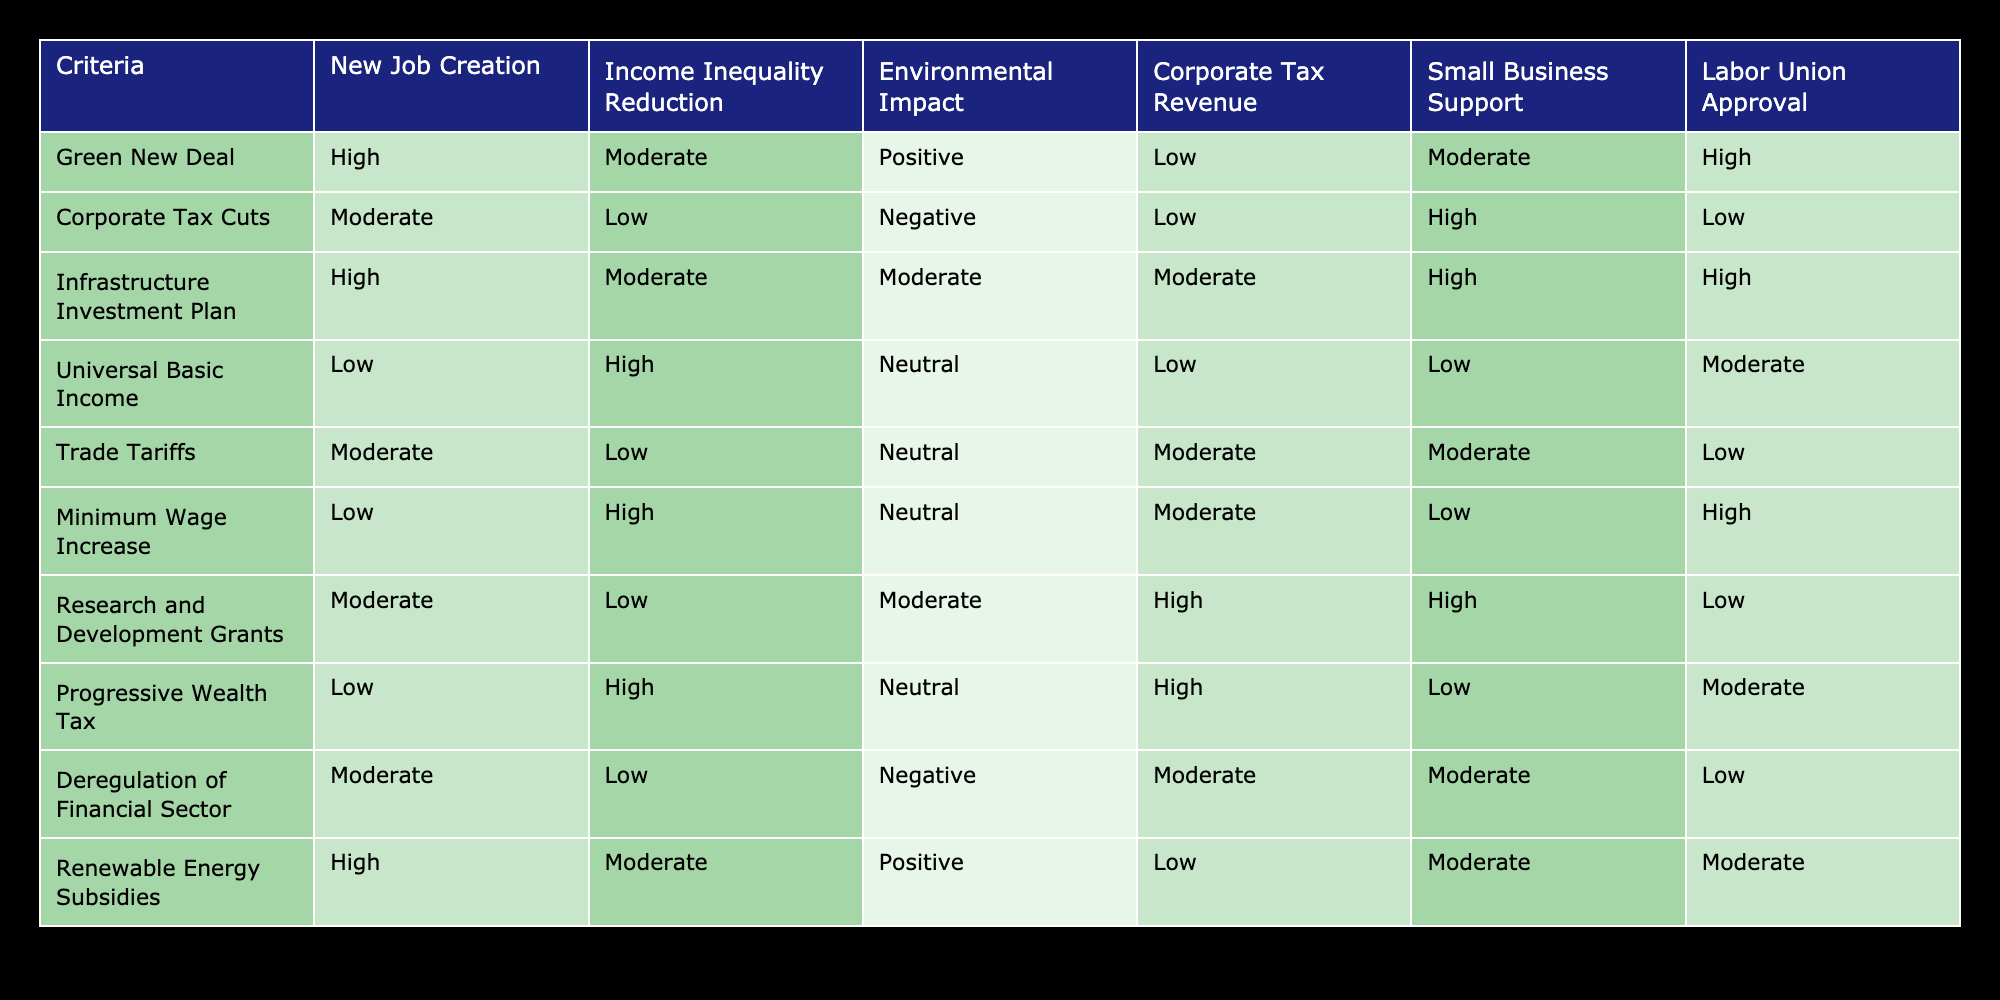What policy has the highest corporate tax revenue? From the table, the "Research and Development Grants" has a "High" rating for Corporate Tax Revenue.
Answer: Research and Development Grants Which policies support small businesses? The "Corporate Tax Cuts," "Infrastructure Investment Plan," and "Renewable Energy Subsidies" all have a "High" rating for Small Business Support.
Answer: Corporate Tax Cuts, Infrastructure Investment Plan, Renewable Energy Subsidies Is there any policy with both high job creation and high corporate tax revenue? By checking the table, no policies have both a "High" rating for New Job Creation and Corporate Tax Revenue simultaneously.
Answer: No Which policy has the lowest rating for income inequality reduction? The "Corporate Tax Cuts" have a "Low" rating for Income Inequality Reduction.
Answer: Corporate Tax Cuts What is the average rating for environmental impact across the policies? The environmental impact ratings from the table: Positive (3), Neutral (3), Negative (2). Thus, the average is (3x2 + 3x1 + 2x0) / 8 = 0.625 which is Neutral.
Answer: Neutral Are there any policies that have high ratings for both labor union approval and income inequality reduction? The "Green New Deal" and "Minimum Wage Increase" have a "High" rating for Labor Union Approval and a "Moderate" and "High" rating for Income Inequality Reduction respectively. So, the "Minimum Wage Increase" qualifies.
Answer: Yes What percentage of the policies result in a positive environmental impact? Among the ten policies, "Green New Deal" and "Renewable Energy Subsidies" are rated Positive, which is 2 out of 10, so the percentage is (2/10) * 100 = 20%.
Answer: 20% Which policy is likely to receive high approval from labor unions but low support for small businesses? The "Corporate Tax Cuts" have a "Low" rating for Small Business Support and a "Low" rating for Labor Union Approval. Therefore, it does not fit the criteria. The only one that does is “Progressive Wealth Tax” with a "Moderate" approval for labor unions.
Answer: Progressive Wealth Tax 